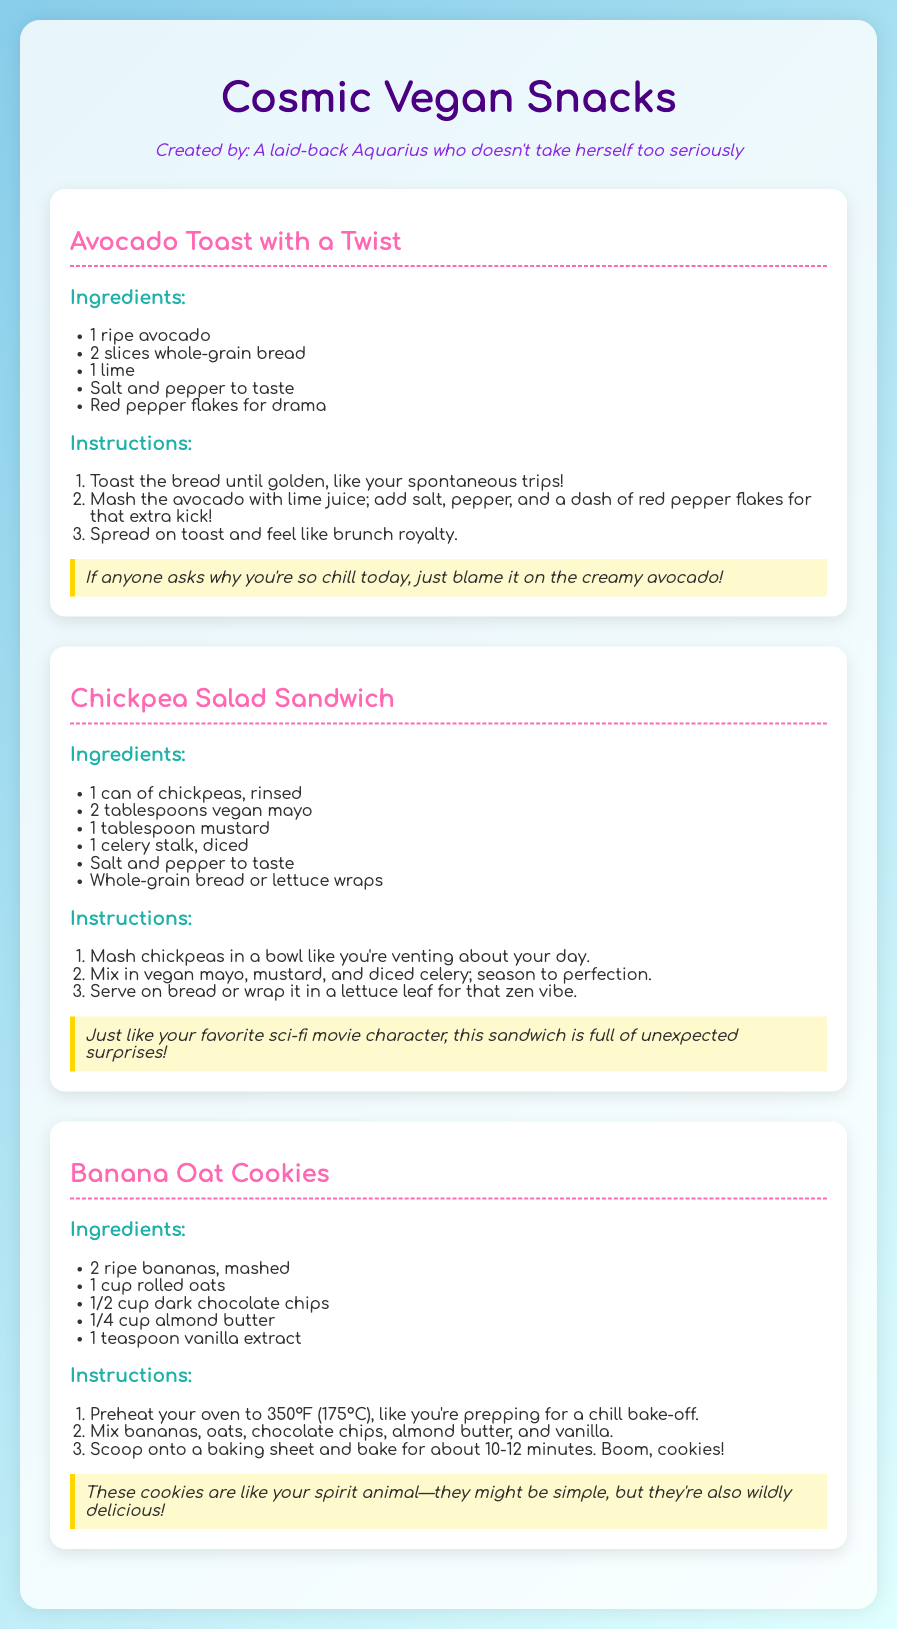What is the name of the first recipe? The first recipe listed in the document is "Avocado Toast with a Twist".
Answer: Avocado Toast with a Twist How many slices of bread are required for the first snack? The recipe for "Avocado Toast with a Twist" requires 2 slices of whole-grain bread.
Answer: 2 slices What ingredient adds a kick to the Avocado Toast? The recipe mentions adding red pepper flakes for that extra kick.
Answer: Red pepper flakes What is the main ingredient in the Chickpea Salad Sandwich? The Chickpea Salad Sandwich uses 1 can of chickpeas as its primary ingredient.
Answer: chickpeas How long should the Banana Oat Cookies be baked? The instructions specify baking the cookies for about 10-12 minutes.
Answer: 10-12 minutes What is the quirky note for the Chickpea Salad Sandwich? The quirky note mentions the sandwich being full of unexpected surprises like a sci-fi movie character.
Answer: full of unexpected surprises What is used for sweetness in the Banana Oat Cookies? The recipe lists 2 ripe bananas, mashed, as the source of sweetness.
Answer: ripe bananas How many total snacks are presented in the document? The document features a total of three snack recipes.
Answer: three 